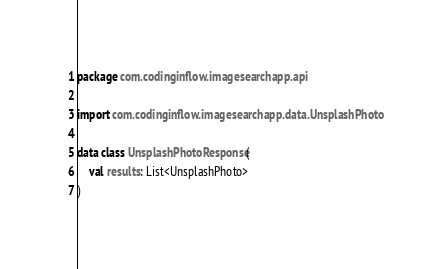Convert code to text. <code><loc_0><loc_0><loc_500><loc_500><_Kotlin_>package com.codinginflow.imagesearchapp.api

import com.codinginflow.imagesearchapp.data.UnsplashPhoto

data class UnsplashPhotoResponse(
    val results: List<UnsplashPhoto>
)</code> 